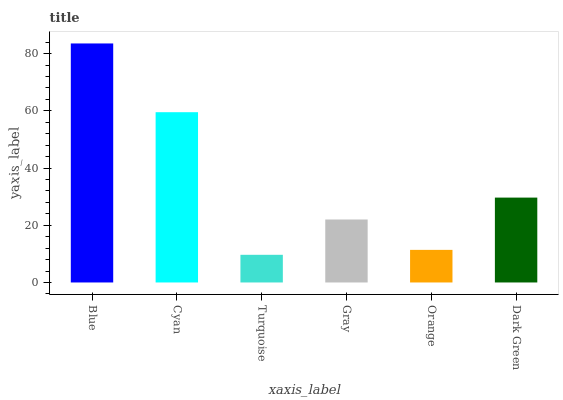Is Turquoise the minimum?
Answer yes or no. Yes. Is Blue the maximum?
Answer yes or no. Yes. Is Cyan the minimum?
Answer yes or no. No. Is Cyan the maximum?
Answer yes or no. No. Is Blue greater than Cyan?
Answer yes or no. Yes. Is Cyan less than Blue?
Answer yes or no. Yes. Is Cyan greater than Blue?
Answer yes or no. No. Is Blue less than Cyan?
Answer yes or no. No. Is Dark Green the high median?
Answer yes or no. Yes. Is Gray the low median?
Answer yes or no. Yes. Is Cyan the high median?
Answer yes or no. No. Is Dark Green the low median?
Answer yes or no. No. 